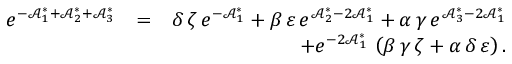<formula> <loc_0><loc_0><loc_500><loc_500>\begin{array} { r l r } { e ^ { - \mathcal { A } _ { 1 } ^ { \ast } + \mathcal { A } _ { 2 } ^ { \ast } + \mathcal { A } _ { 3 } ^ { \ast } } } & { = } & { \delta \, \zeta \, e ^ { - \mathcal { A } _ { 1 } ^ { \ast } } + \beta \, \varepsilon \, e ^ { \mathcal { A } _ { 2 } ^ { \ast } - 2 \mathcal { A } _ { 1 } ^ { \ast } } + \alpha \, \gamma \, e ^ { \mathcal { A } _ { 3 } ^ { \ast } - 2 \mathcal { A } _ { 1 } ^ { \ast } } } \\ & { + e ^ { - 2 \mathcal { A } _ { 1 } ^ { \ast } } \, \left ( \beta \, \gamma \, \zeta + \alpha \, \delta \, \varepsilon \right ) . } \end{array}</formula> 